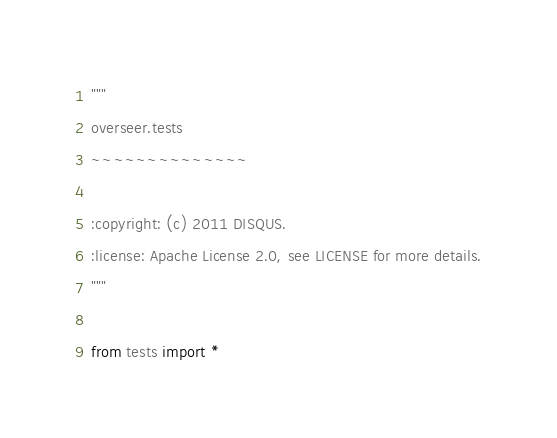Convert code to text. <code><loc_0><loc_0><loc_500><loc_500><_Python_>"""
overseer.tests
~~~~~~~~~~~~~~

:copyright: (c) 2011 DISQUS.
:license: Apache License 2.0, see LICENSE for more details.
"""

from tests import *</code> 